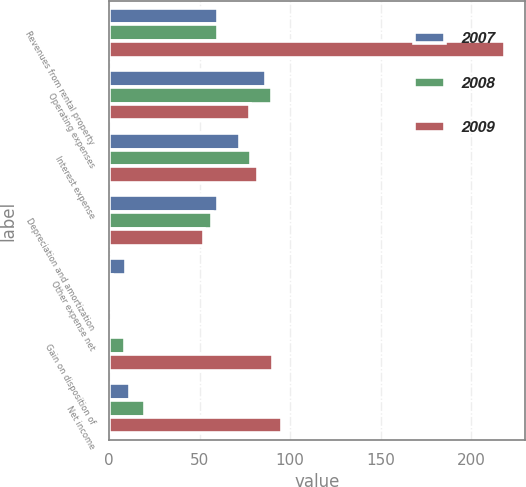Convert chart to OTSL. <chart><loc_0><loc_0><loc_500><loc_500><stacked_bar_chart><ecel><fcel>Revenues from rental property<fcel>Operating expenses<fcel>Interest expense<fcel>Depreciation and amortization<fcel>Other expense net<fcel>Gain on disposition of<fcel>Net income<nl><fcel>2007<fcel>59.9<fcel>86.4<fcel>72.1<fcel>59.9<fcel>9.3<fcel>1.6<fcel>11.6<nl><fcel>2008<fcel>59.9<fcel>90.1<fcel>78.1<fcel>56.6<fcel>1.7<fcel>8.5<fcel>20<nl><fcel>2009<fcel>218.7<fcel>77.9<fcel>82.2<fcel>52.1<fcel>1.6<fcel>90.5<fcel>95.4<nl></chart> 